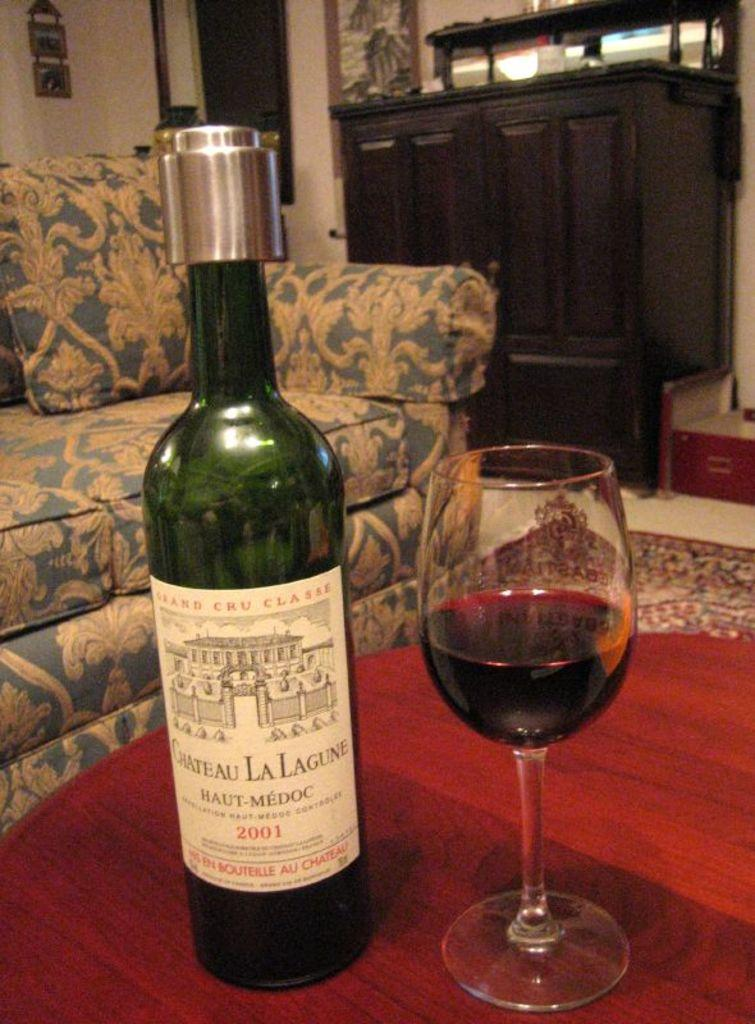<image>
Create a compact narrative representing the image presented. A bottle of Chateau La Lagune is beside a wine glass on a table. 